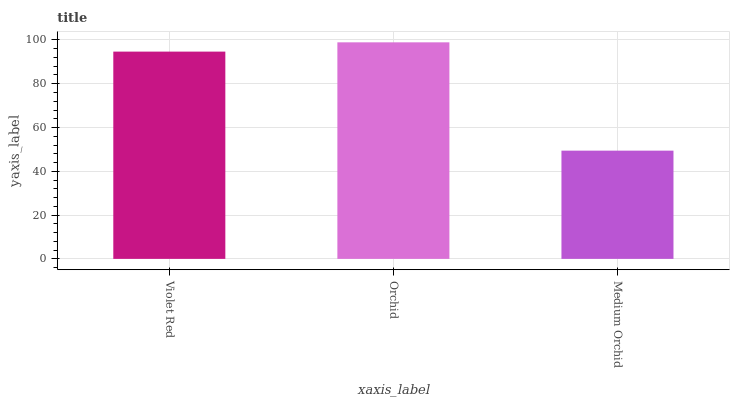Is Orchid the minimum?
Answer yes or no. No. Is Medium Orchid the maximum?
Answer yes or no. No. Is Orchid greater than Medium Orchid?
Answer yes or no. Yes. Is Medium Orchid less than Orchid?
Answer yes or no. Yes. Is Medium Orchid greater than Orchid?
Answer yes or no. No. Is Orchid less than Medium Orchid?
Answer yes or no. No. Is Violet Red the high median?
Answer yes or no. Yes. Is Violet Red the low median?
Answer yes or no. Yes. Is Medium Orchid the high median?
Answer yes or no. No. Is Medium Orchid the low median?
Answer yes or no. No. 